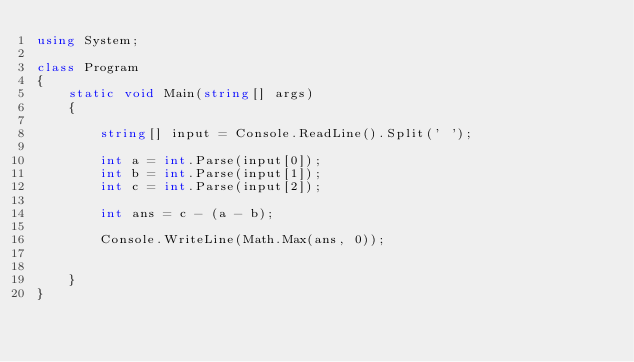Convert code to text. <code><loc_0><loc_0><loc_500><loc_500><_C#_>using System;

class Program
{
    static void Main(string[] args)
    {

        string[] input = Console.ReadLine().Split(' ');

        int a = int.Parse(input[0]);
        int b = int.Parse(input[1]);
        int c = int.Parse(input[2]);

        int ans = c - (a - b);

        Console.WriteLine(Math.Max(ans, 0));


    }
}

</code> 